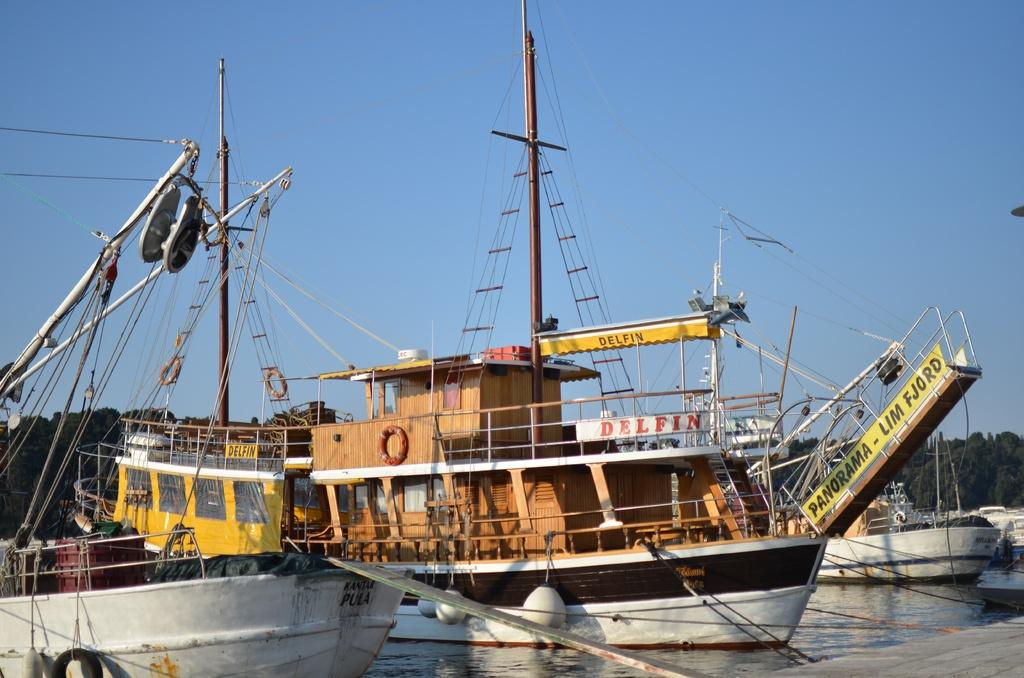What type of vehicles are in the water in the image? There are ships in the water in the image. What can be seen in the background of the image? There are trees in the background of the image. What type of birds can be seen flying in the image? There are no birds visible in the image; it only features ships in the water and trees in the background. 